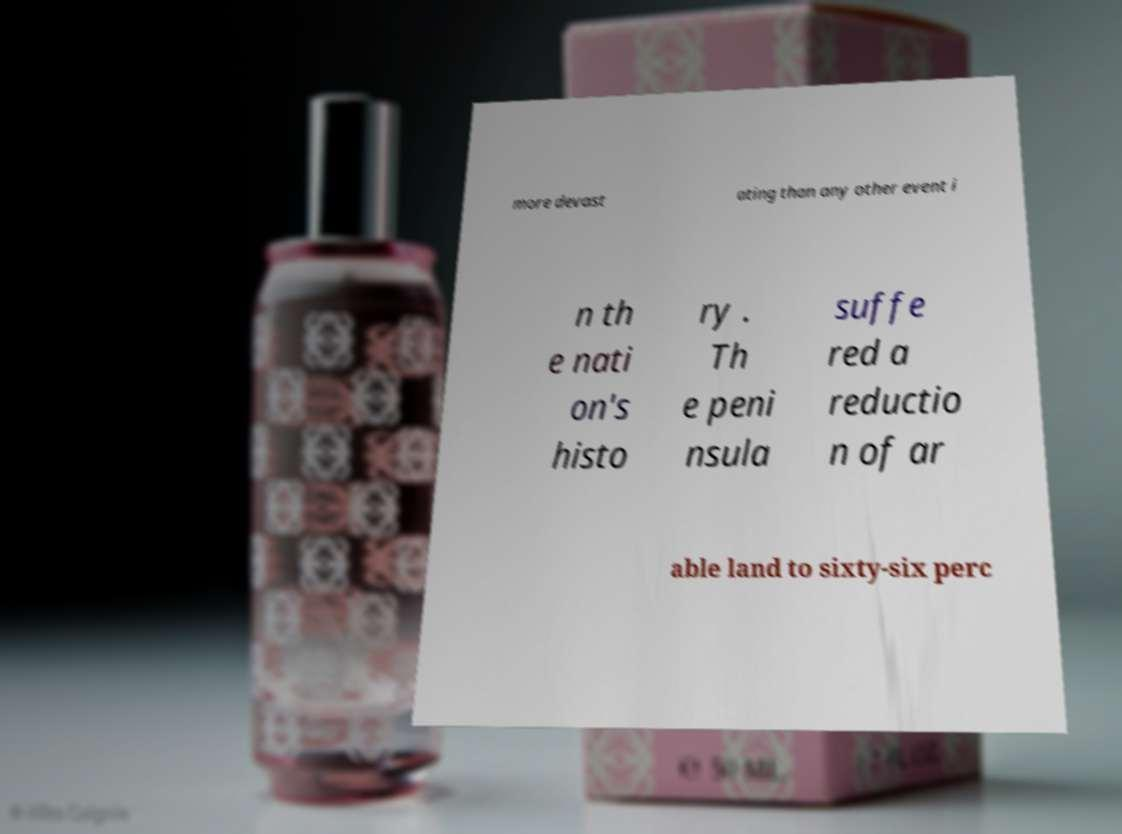For documentation purposes, I need the text within this image transcribed. Could you provide that? more devast ating than any other event i n th e nati on's histo ry . Th e peni nsula suffe red a reductio n of ar able land to sixty-six perc 